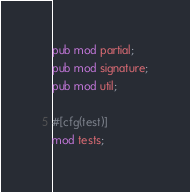Convert code to text. <code><loc_0><loc_0><loc_500><loc_500><_Rust_>pub mod partial;
pub mod signature;
pub mod util;

#[cfg(test)]
mod tests;
</code> 